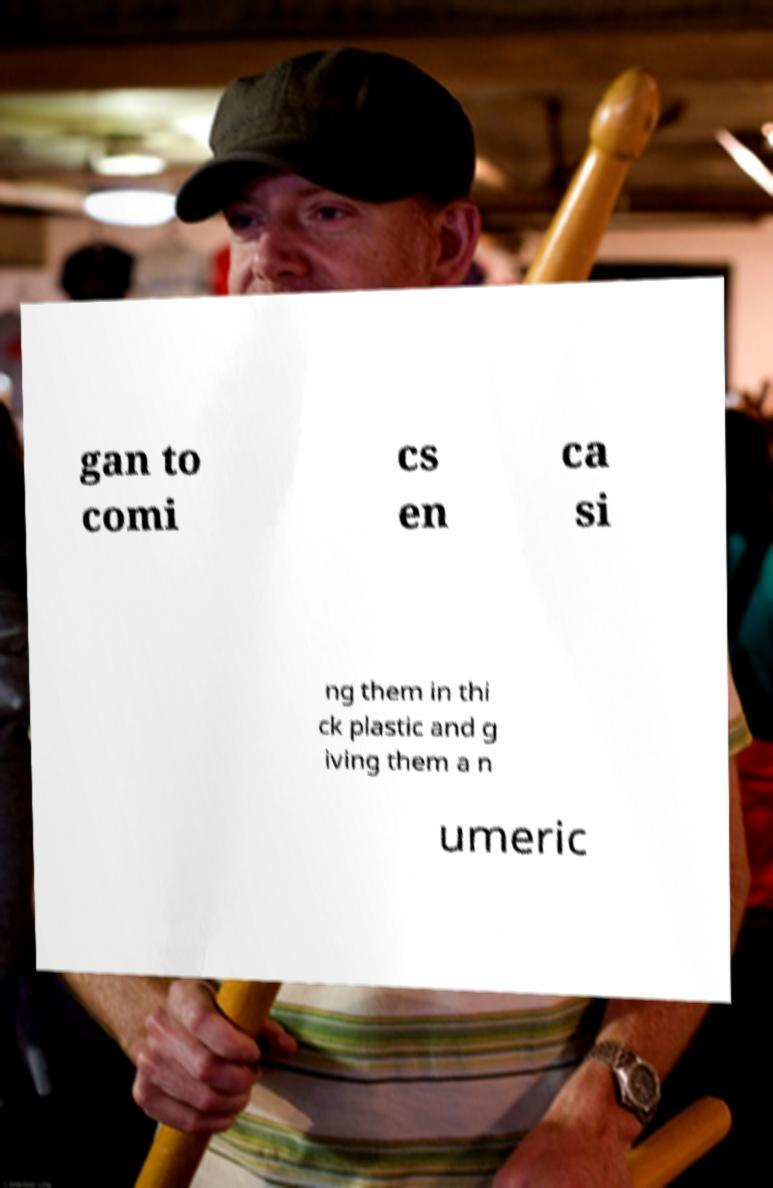Could you extract and type out the text from this image? gan to comi cs en ca si ng them in thi ck plastic and g iving them a n umeric 